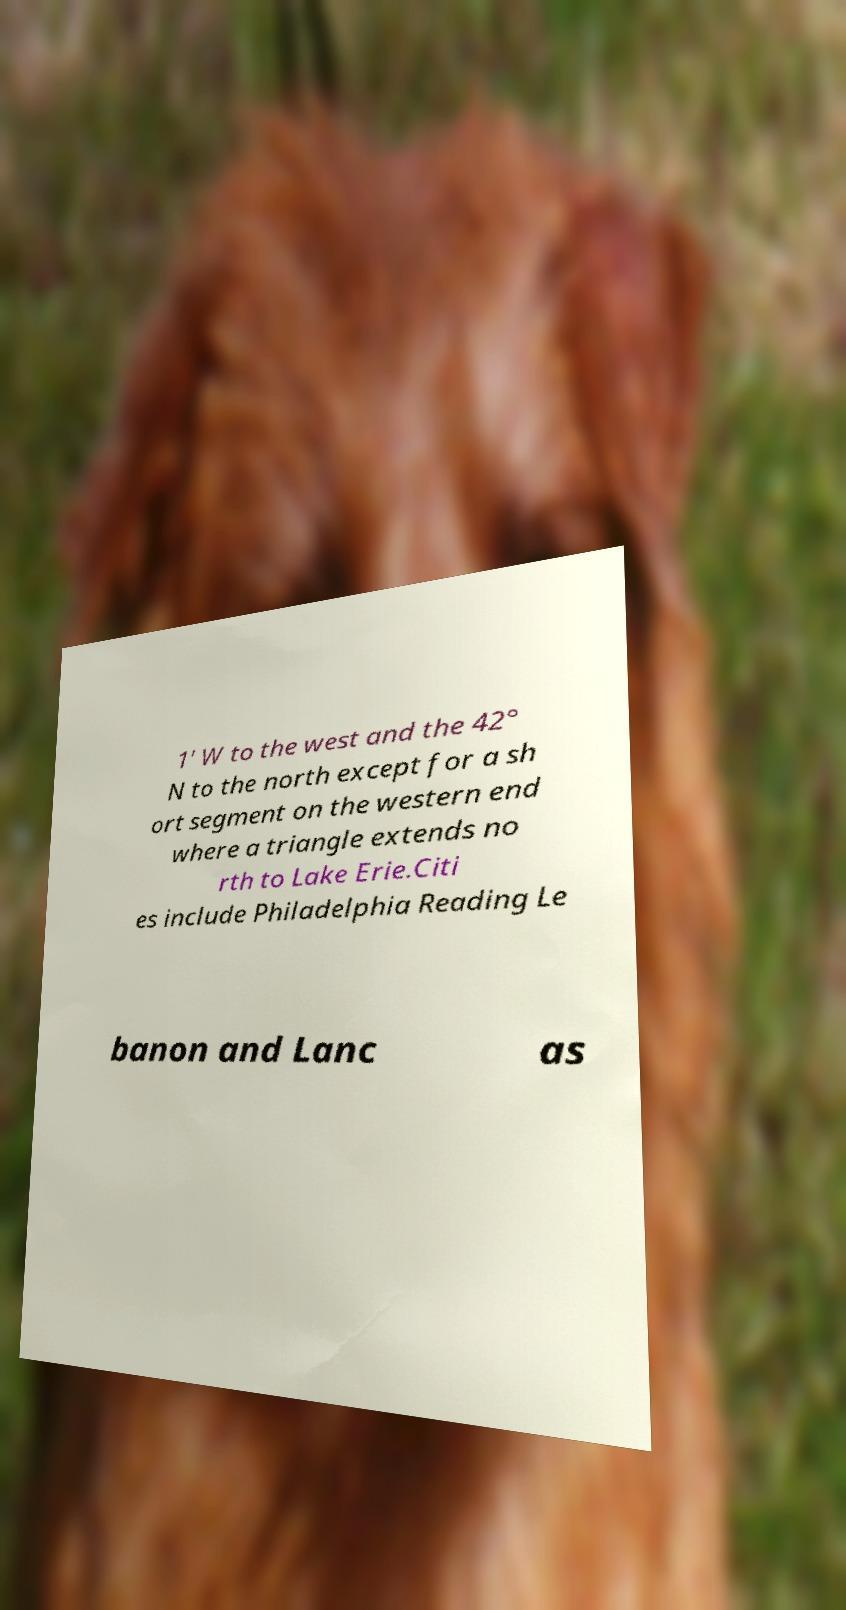Please identify and transcribe the text found in this image. 1' W to the west and the 42° N to the north except for a sh ort segment on the western end where a triangle extends no rth to Lake Erie.Citi es include Philadelphia Reading Le banon and Lanc as 